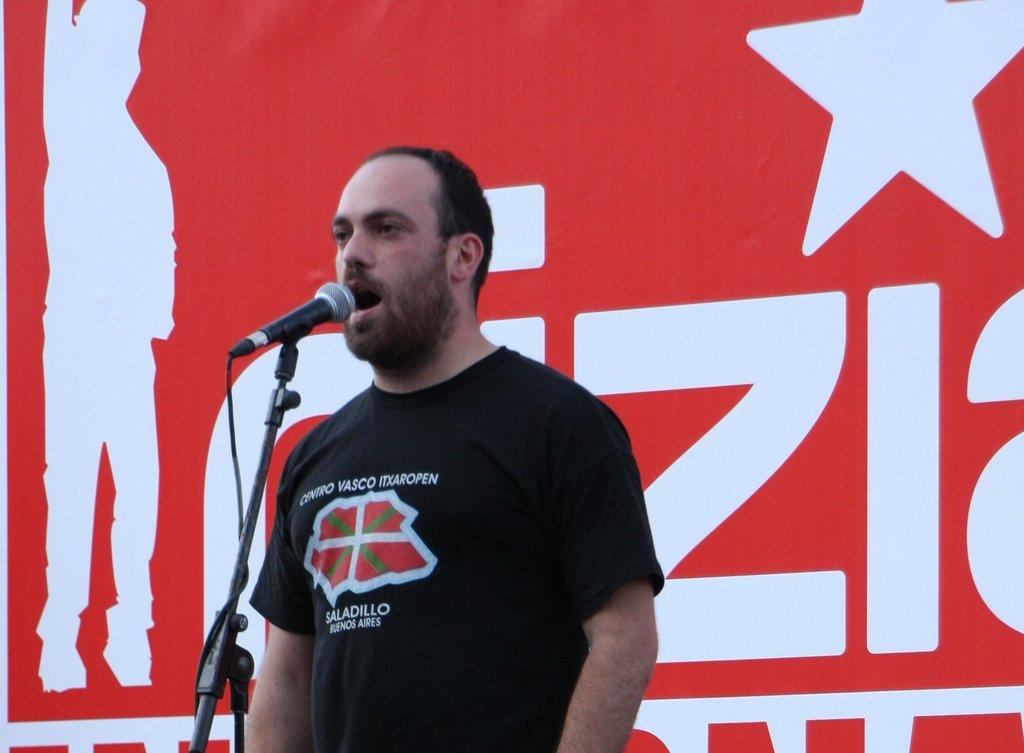Who is present in the image? There is a man in the image. What is the man doing in the image? The man is speaking in the image. What object is associated with the man's activity in the image? There is a microphone in the image. What type of food is the man eating in the image? There is no food present in the image; the man is speaking into a microphone. 